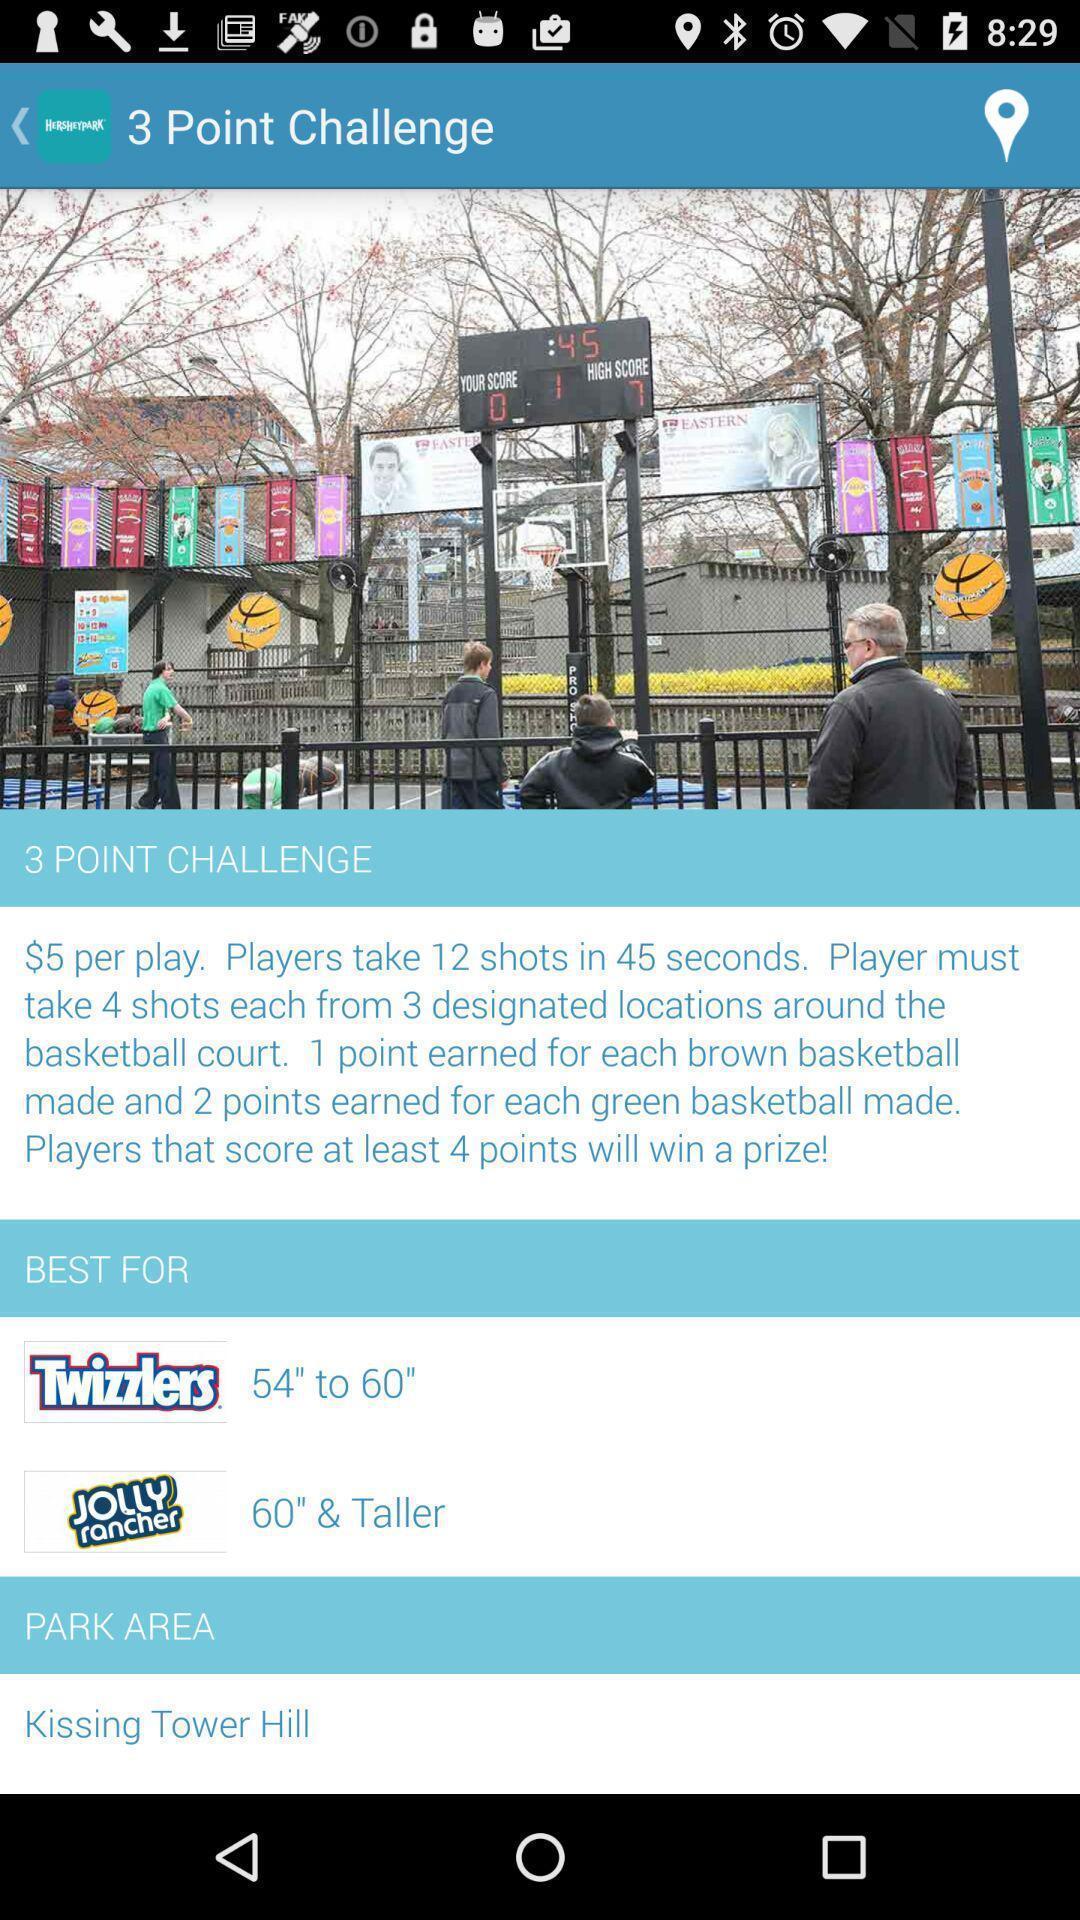Provide a detailed account of this screenshot. Screen showing 3 point challenge. 